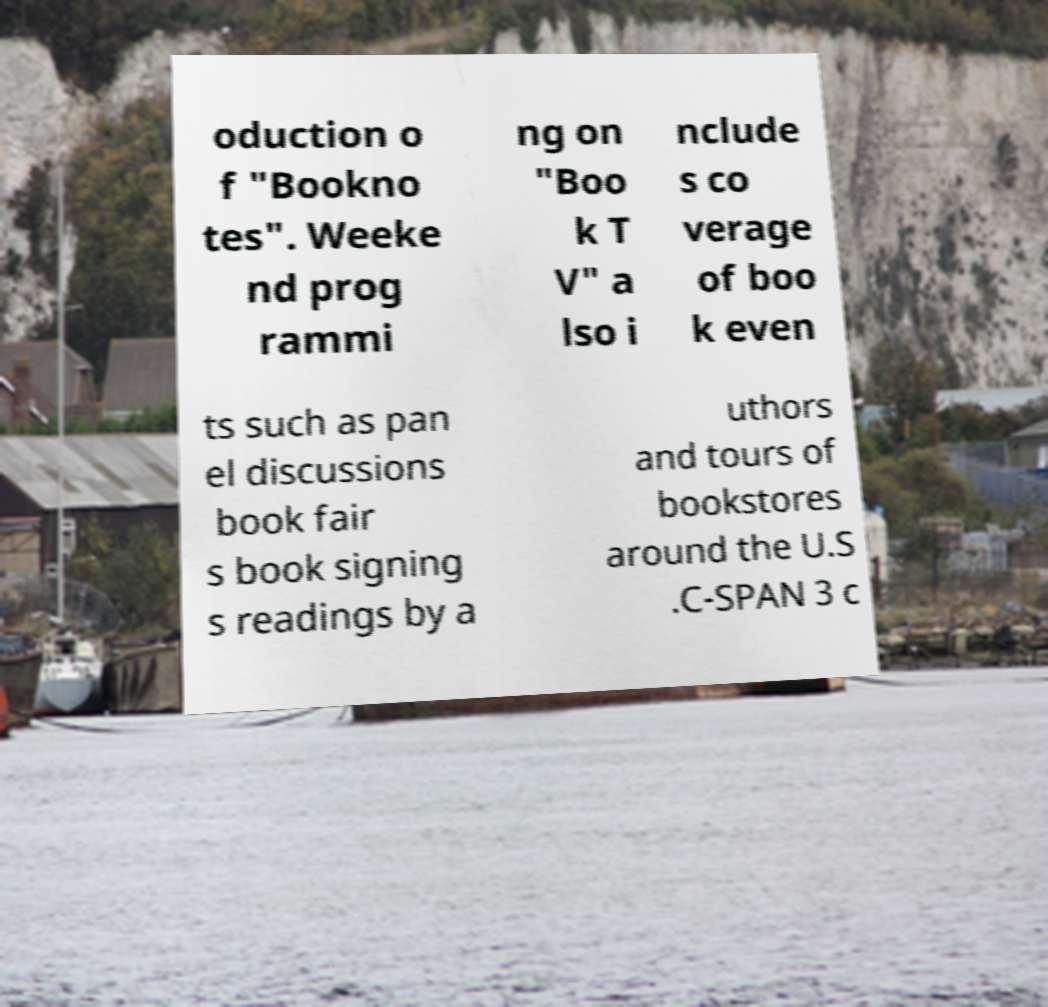Can you read and provide the text displayed in the image?This photo seems to have some interesting text. Can you extract and type it out for me? oduction o f "Bookno tes". Weeke nd prog rammi ng on "Boo k T V" a lso i nclude s co verage of boo k even ts such as pan el discussions book fair s book signing s readings by a uthors and tours of bookstores around the U.S .C-SPAN 3 c 